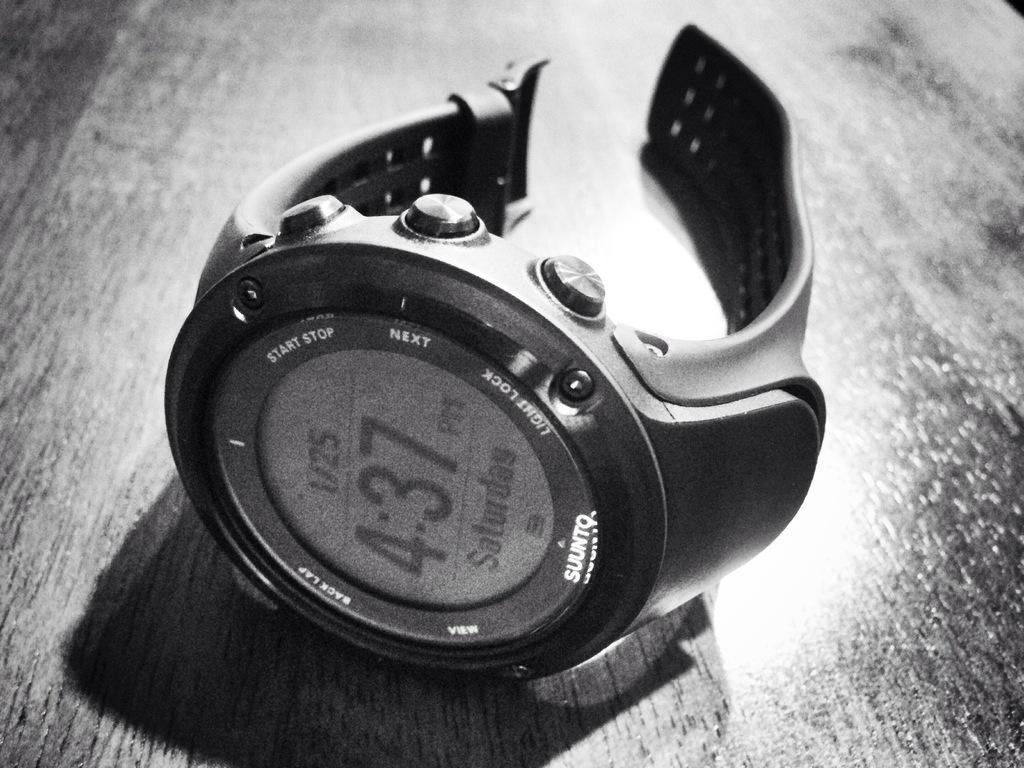<image>
Summarize the visual content of the image. The brand of digital watch is a SUUNTQ 